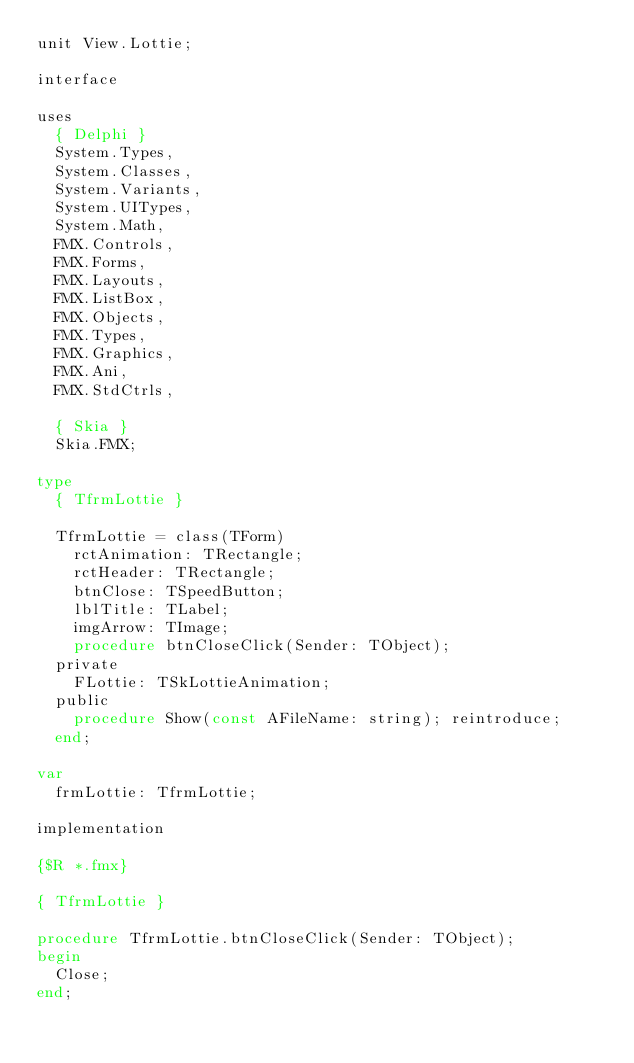Convert code to text. <code><loc_0><loc_0><loc_500><loc_500><_Pascal_>unit View.Lottie;

interface

uses
  { Delphi }
  System.Types,
  System.Classes,
  System.Variants,
  System.UITypes,
  System.Math,
  FMX.Controls,
  FMX.Forms,
  FMX.Layouts,
  FMX.ListBox,
  FMX.Objects,
  FMX.Types,
  FMX.Graphics,
  FMX.Ani,
  FMX.StdCtrls,

  { Skia }
  Skia.FMX;

type
  { TfrmLottie }

  TfrmLottie = class(TForm)
    rctAnimation: TRectangle;
    rctHeader: TRectangle;
    btnClose: TSpeedButton;
    lblTitle: TLabel;
    imgArrow: TImage;
    procedure btnCloseClick(Sender: TObject);
  private
    FLottie: TSkLottieAnimation;
  public
    procedure Show(const AFileName: string); reintroduce;
  end;

var
  frmLottie: TfrmLottie;

implementation

{$R *.fmx}

{ TfrmLottie }

procedure TfrmLottie.btnCloseClick(Sender: TObject);
begin
  Close;
end;
</code> 